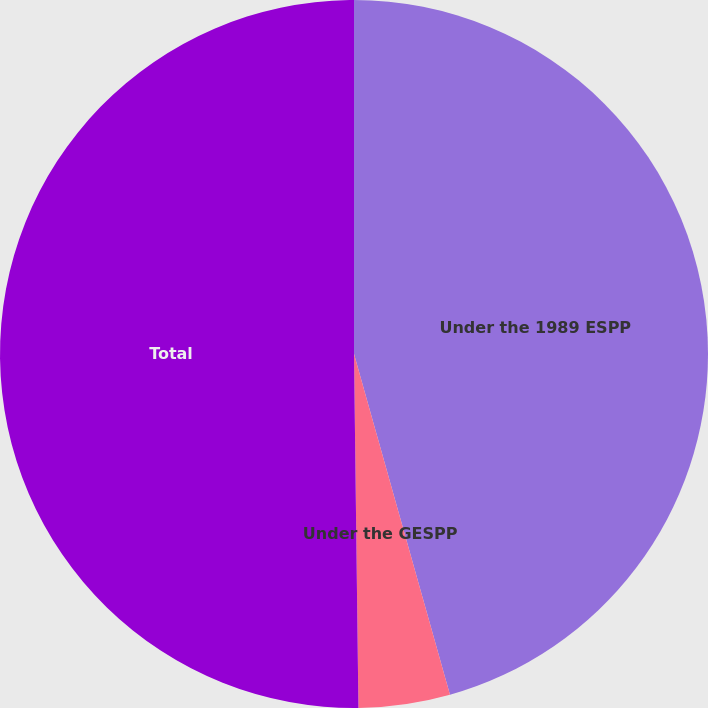Convert chart. <chart><loc_0><loc_0><loc_500><loc_500><pie_chart><fcel>Under the 1989 ESPP<fcel>Under the GESPP<fcel>Total<nl><fcel>45.63%<fcel>4.17%<fcel>50.2%<nl></chart> 